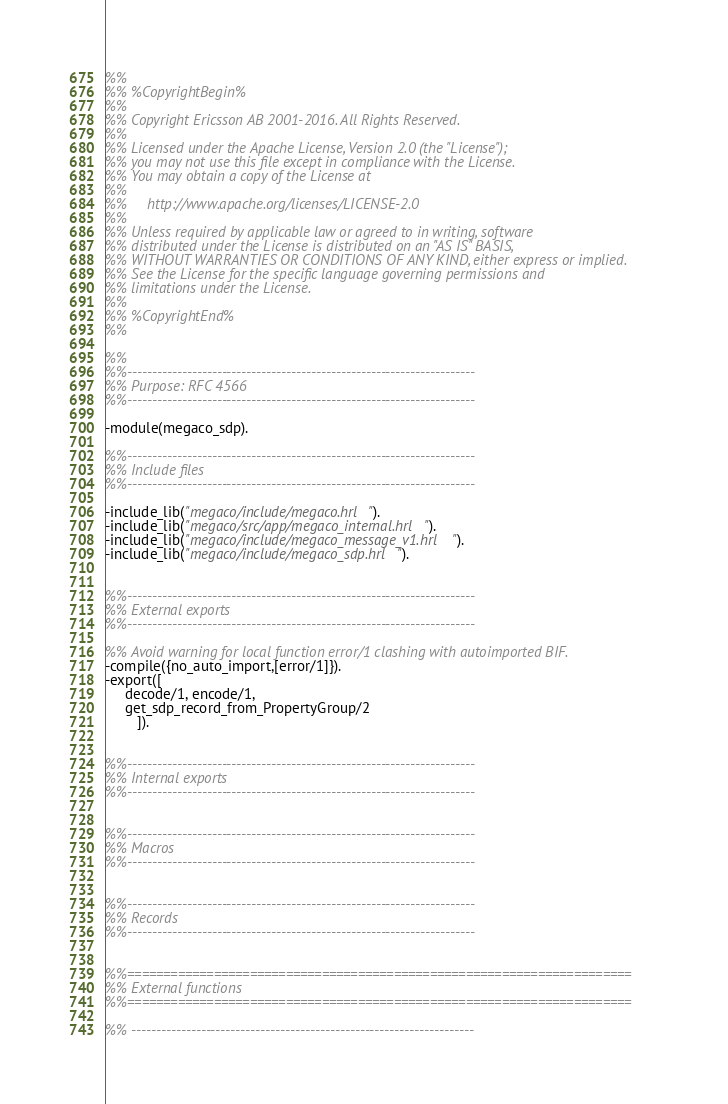Convert code to text. <code><loc_0><loc_0><loc_500><loc_500><_Erlang_>%%
%% %CopyrightBegin%
%% 
%% Copyright Ericsson AB 2001-2016. All Rights Reserved.
%% 
%% Licensed under the Apache License, Version 2.0 (the "License");
%% you may not use this file except in compliance with the License.
%% You may obtain a copy of the License at
%%
%%     http://www.apache.org/licenses/LICENSE-2.0
%%
%% Unless required by applicable law or agreed to in writing, software
%% distributed under the License is distributed on an "AS IS" BASIS,
%% WITHOUT WARRANTIES OR CONDITIONS OF ANY KIND, either express or implied.
%% See the License for the specific language governing permissions and
%% limitations under the License.
%% 
%% %CopyrightEnd%
%%

%%
%%----------------------------------------------------------------------
%% Purpose: RFC 4566
%%----------------------------------------------------------------------

-module(megaco_sdp).

%%----------------------------------------------------------------------
%% Include files
%%----------------------------------------------------------------------

-include_lib("megaco/include/megaco.hrl").
-include_lib("megaco/src/app/megaco_internal.hrl").
-include_lib("megaco/include/megaco_message_v1.hrl").
-include_lib("megaco/include/megaco_sdp.hrl").


%%----------------------------------------------------------------------
%% External exports
%%----------------------------------------------------------------------

%% Avoid warning for local function error/1 clashing with autoimported BIF.
-compile({no_auto_import,[error/1]}).
-export([
	 decode/1, encode/1, 
	 get_sdp_record_from_PropertyGroup/2
        ]).


%%----------------------------------------------------------------------
%% Internal exports
%%----------------------------------------------------------------------


%%----------------------------------------------------------------------
%% Macros
%%----------------------------------------------------------------------


%%----------------------------------------------------------------------
%% Records
%%----------------------------------------------------------------------


%%======================================================================
%% External functions
%%======================================================================

%% ---------------------------------------------------------------------</code> 